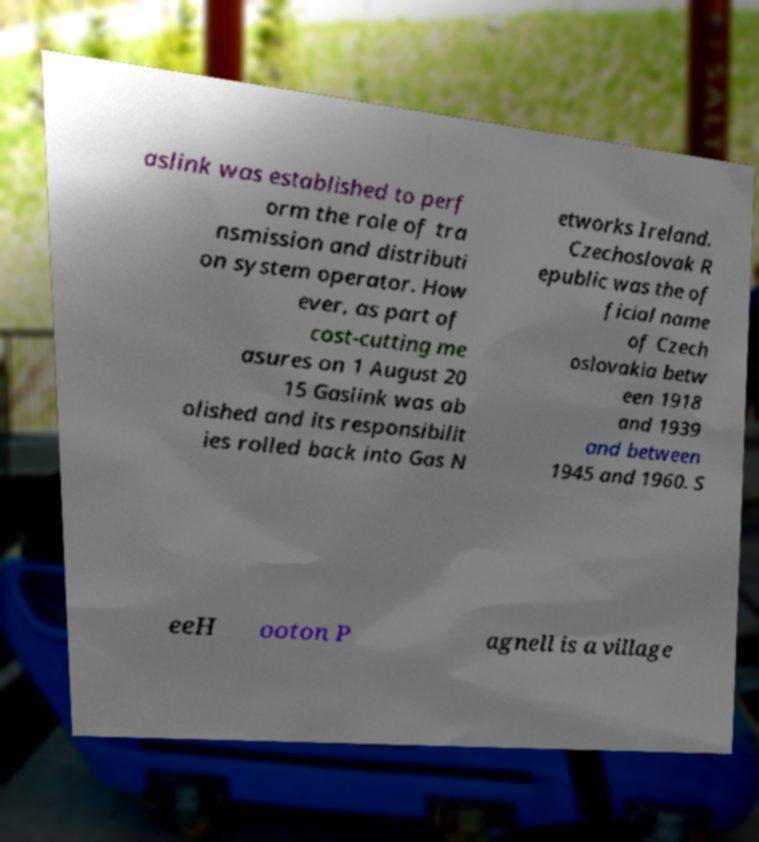Can you read and provide the text displayed in the image?This photo seems to have some interesting text. Can you extract and type it out for me? aslink was established to perf orm the role of tra nsmission and distributi on system operator. How ever, as part of cost-cutting me asures on 1 August 20 15 Gaslink was ab olished and its responsibilit ies rolled back into Gas N etworks Ireland. Czechoslovak R epublic was the of ficial name of Czech oslovakia betw een 1918 and 1939 and between 1945 and 1960. S eeH ooton P agnell is a village 